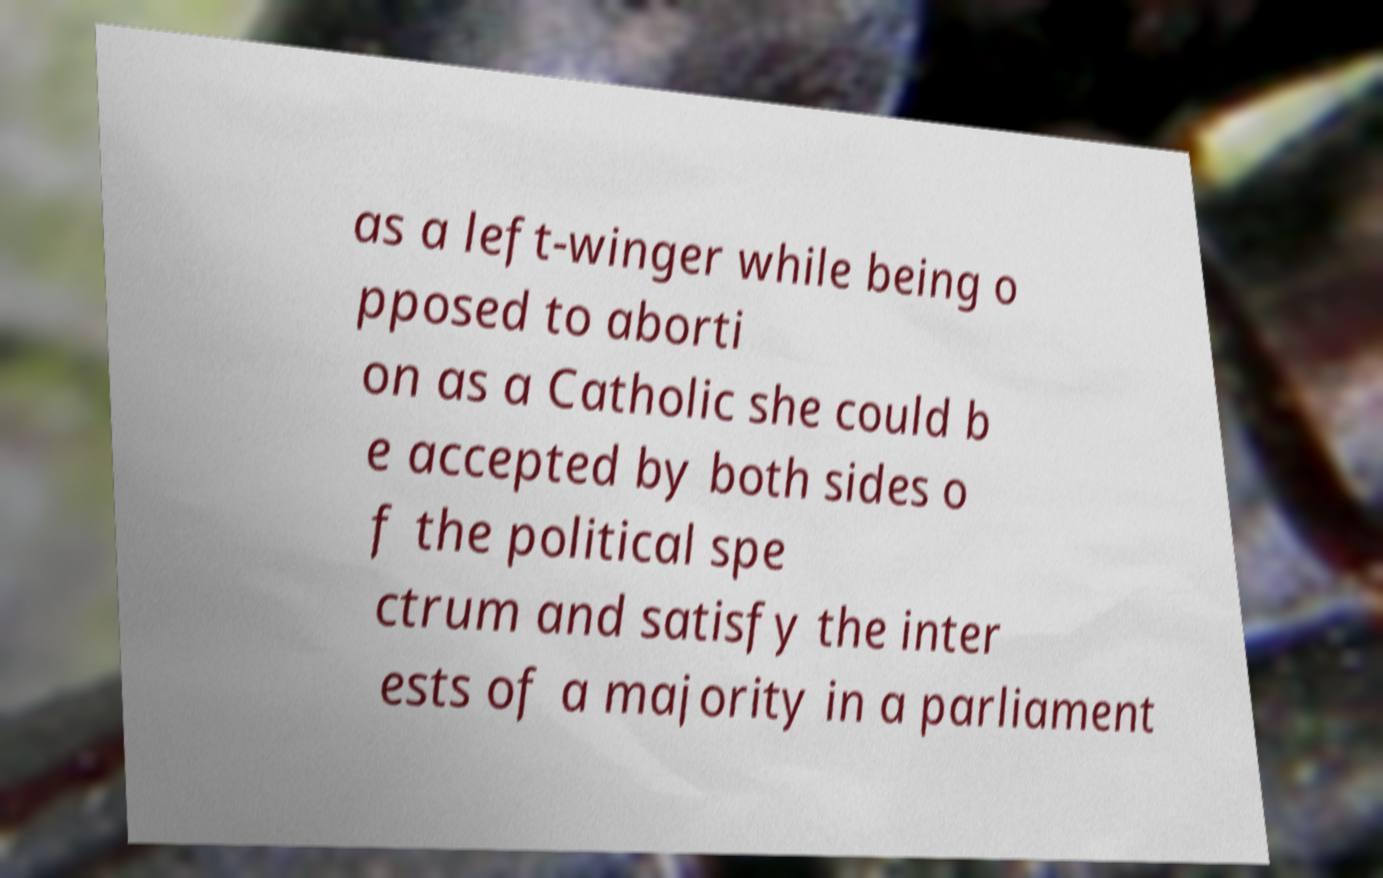Can you accurately transcribe the text from the provided image for me? as a left-winger while being o pposed to aborti on as a Catholic she could b e accepted by both sides o f the political spe ctrum and satisfy the inter ests of a majority in a parliament 